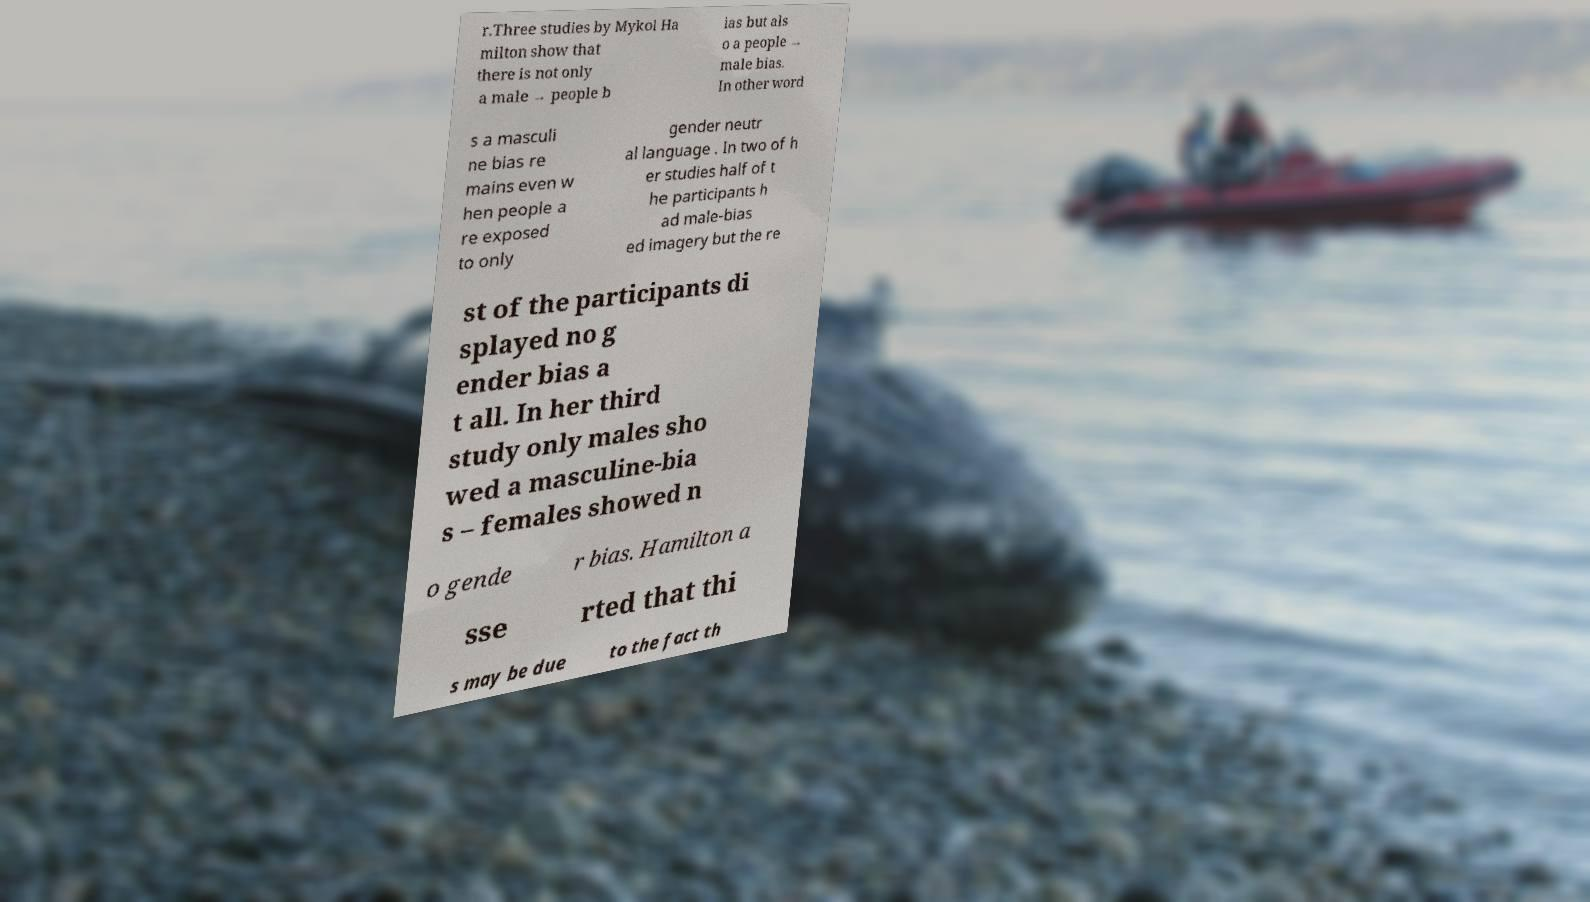Could you assist in decoding the text presented in this image and type it out clearly? r.Three studies by Mykol Ha milton show that there is not only a male → people b ias but als o a people → male bias. In other word s a masculi ne bias re mains even w hen people a re exposed to only gender neutr al language . In two of h er studies half of t he participants h ad male-bias ed imagery but the re st of the participants di splayed no g ender bias a t all. In her third study only males sho wed a masculine-bia s – females showed n o gende r bias. Hamilton a sse rted that thi s may be due to the fact th 